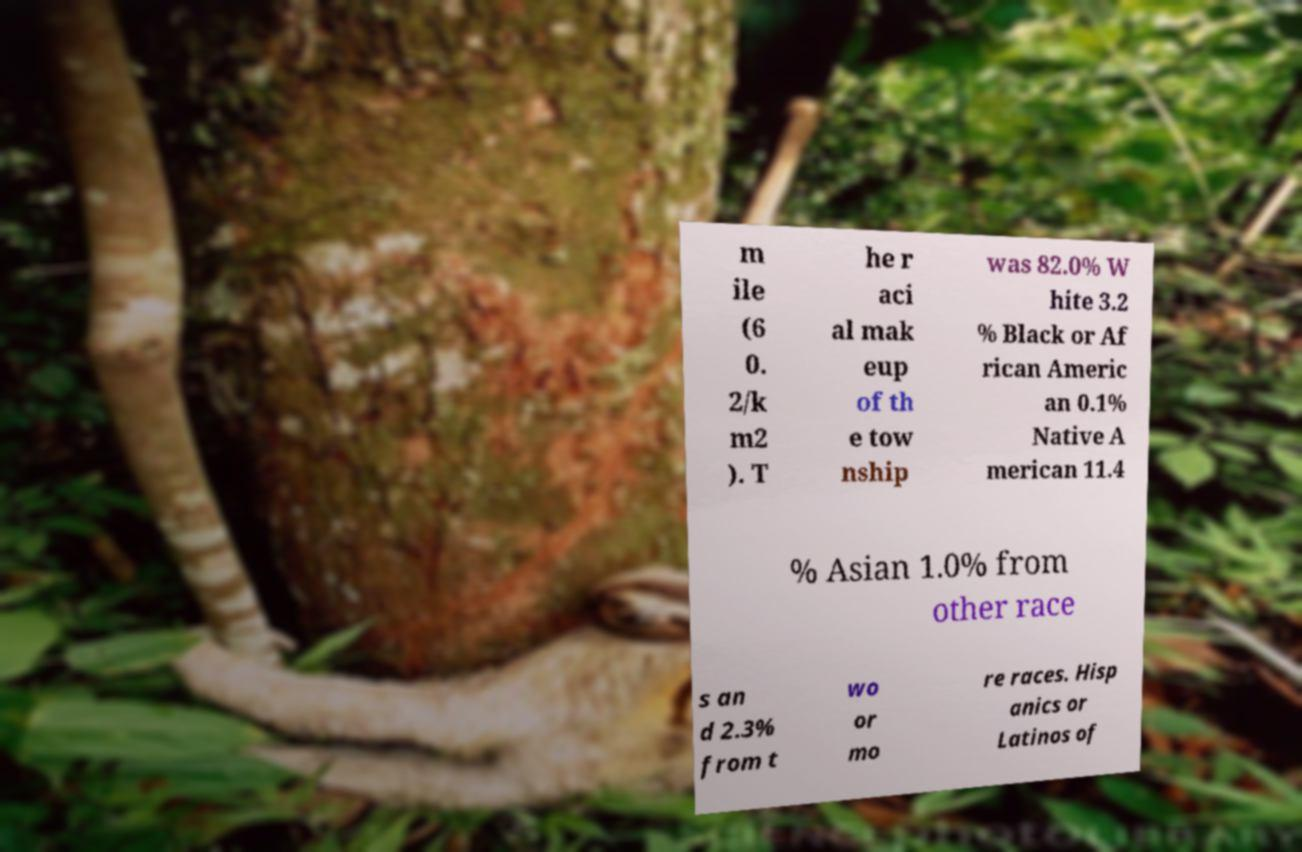Could you assist in decoding the text presented in this image and type it out clearly? m ile (6 0. 2/k m2 ). T he r aci al mak eup of th e tow nship was 82.0% W hite 3.2 % Black or Af rican Americ an 0.1% Native A merican 11.4 % Asian 1.0% from other race s an d 2.3% from t wo or mo re races. Hisp anics or Latinos of 